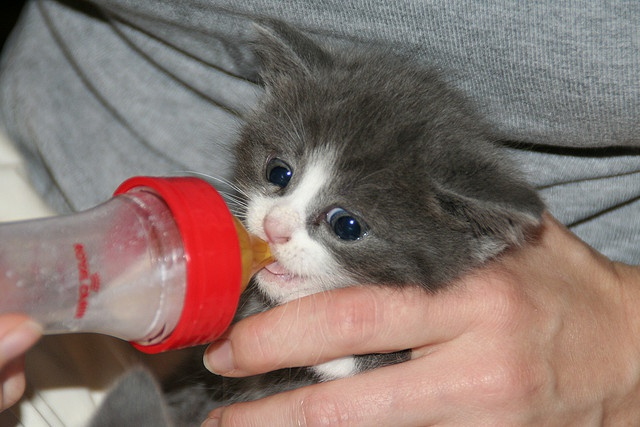Describe the objects in this image and their specific colors. I can see people in gray and black tones, people in black, tan, gray, and maroon tones, cat in black, gray, and lightgray tones, and bottle in black, darkgray, gray, red, and brown tones in this image. 